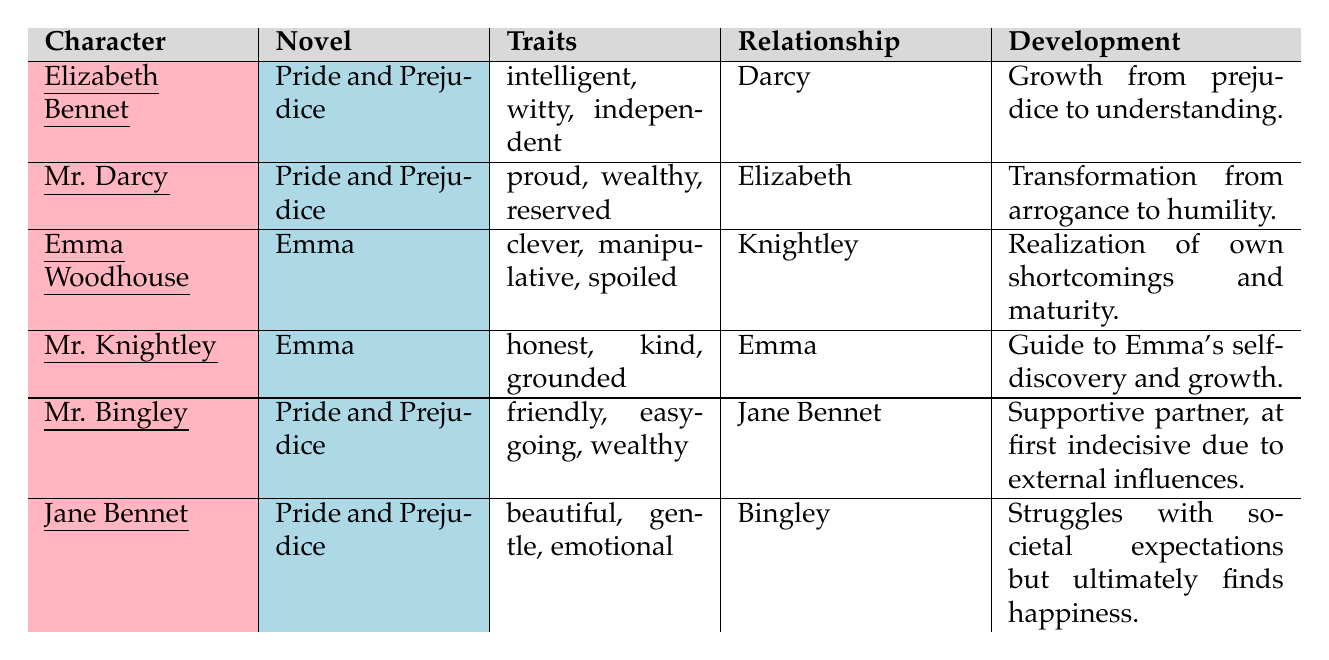What are the traits of Elizabeth Bennet? According to the table under the "Traits" column for Elizabeth Bennet, the listed traits are "intelligent," "witty," and "independent."
Answer: intelligent, witty, independent Which character from "Pride and Prejudice" is described as manipulative? The table shows that Emma Woodhouse, who is from the novel "Emma," is described with the trait "manipulative," and no character from "Pride and Prejudice" has this description.
Answer: No character What kind of development does Mr. Darcy experience in "Pride and Prejudice"? Looking at the "Development" column for Mr. Darcy in the table, it states he undergoes a "transformation from arrogance to humility."
Answer: Transformation from arrogance to humility Who has a relationship with Mr. Knightley? From the "Relationship" column in the table, it can be seen that Mr. Knightley's relationship is with Emma Woodhouse.
Answer: Emma Woodhouse How many characters are listed from "Pride and Prejudice"? By counting the entries under the "Novel" column that feature "Pride and Prejudice," there are three characters: Elizabeth Bennet, Mr. Darcy, Mr. Bingley, totaling three characters.
Answer: 3 Which character from "Emma" is known to be grounded? The table reveals that Mr. Knightley is described as "grounded" among the characters from the novel "Emma."
Answer: Mr. Knightley Is Jane Bennet described as emotional? Yes, the traits listed for Jane Bennet include "emotional," which clearly affirms the statement.
Answer: Yes What is the primary theme of growth in Emma Woodhouse's character development? The table indicates that Emma Woodhouse experiences a "realization of her own shortcomings and maturity," highlighting her character's growth journey.
Answer: Realization of shortcomings and maturity Which traits does Mr. Bingley have according to the table? The table lists Mr. Bingley’s traits as "friendly," "easy-going," and "wealthy."
Answer: friendly, easy-going, wealthy Which character's development focuses on self-discovery? Analyzing the "Development" section, it is clear that Mr. Knightley serves as a "guide to Emma's self-discovery and growth," thus linking self-discovery to Emma Woodhouse.
Answer: Emma Woodhouse What can you conclude about the relationship dynamics between Elizabeth Bennet and Mr. Darcy? In the table, the relationship specified for Elizabeth Bennet is with Mr. Darcy and her development reflects a transition from prejudice to understanding, indicating that their relationship evolves significantly.
Answer: Evolving from prejudice to understanding 